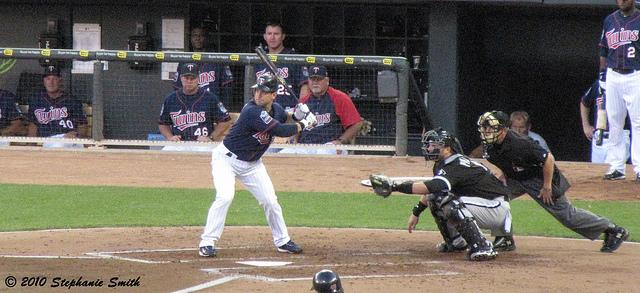What state is the batter's team located in? minnesota 